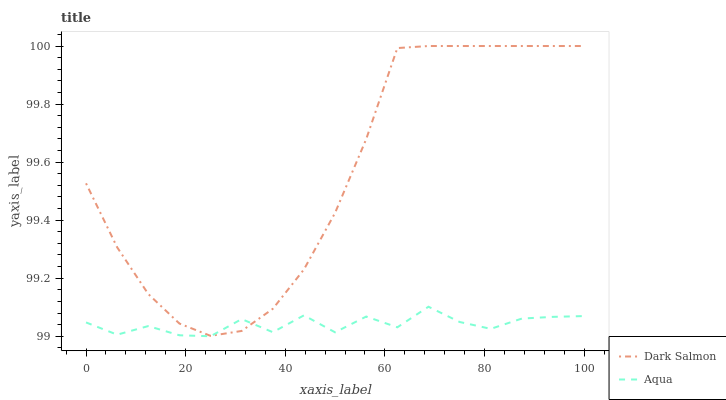Does Aqua have the minimum area under the curve?
Answer yes or no. Yes. Does Dark Salmon have the maximum area under the curve?
Answer yes or no. Yes. Does Dark Salmon have the minimum area under the curve?
Answer yes or no. No. Is Dark Salmon the smoothest?
Answer yes or no. Yes. Is Aqua the roughest?
Answer yes or no. Yes. Is Dark Salmon the roughest?
Answer yes or no. No. Does Dark Salmon have the lowest value?
Answer yes or no. No. 